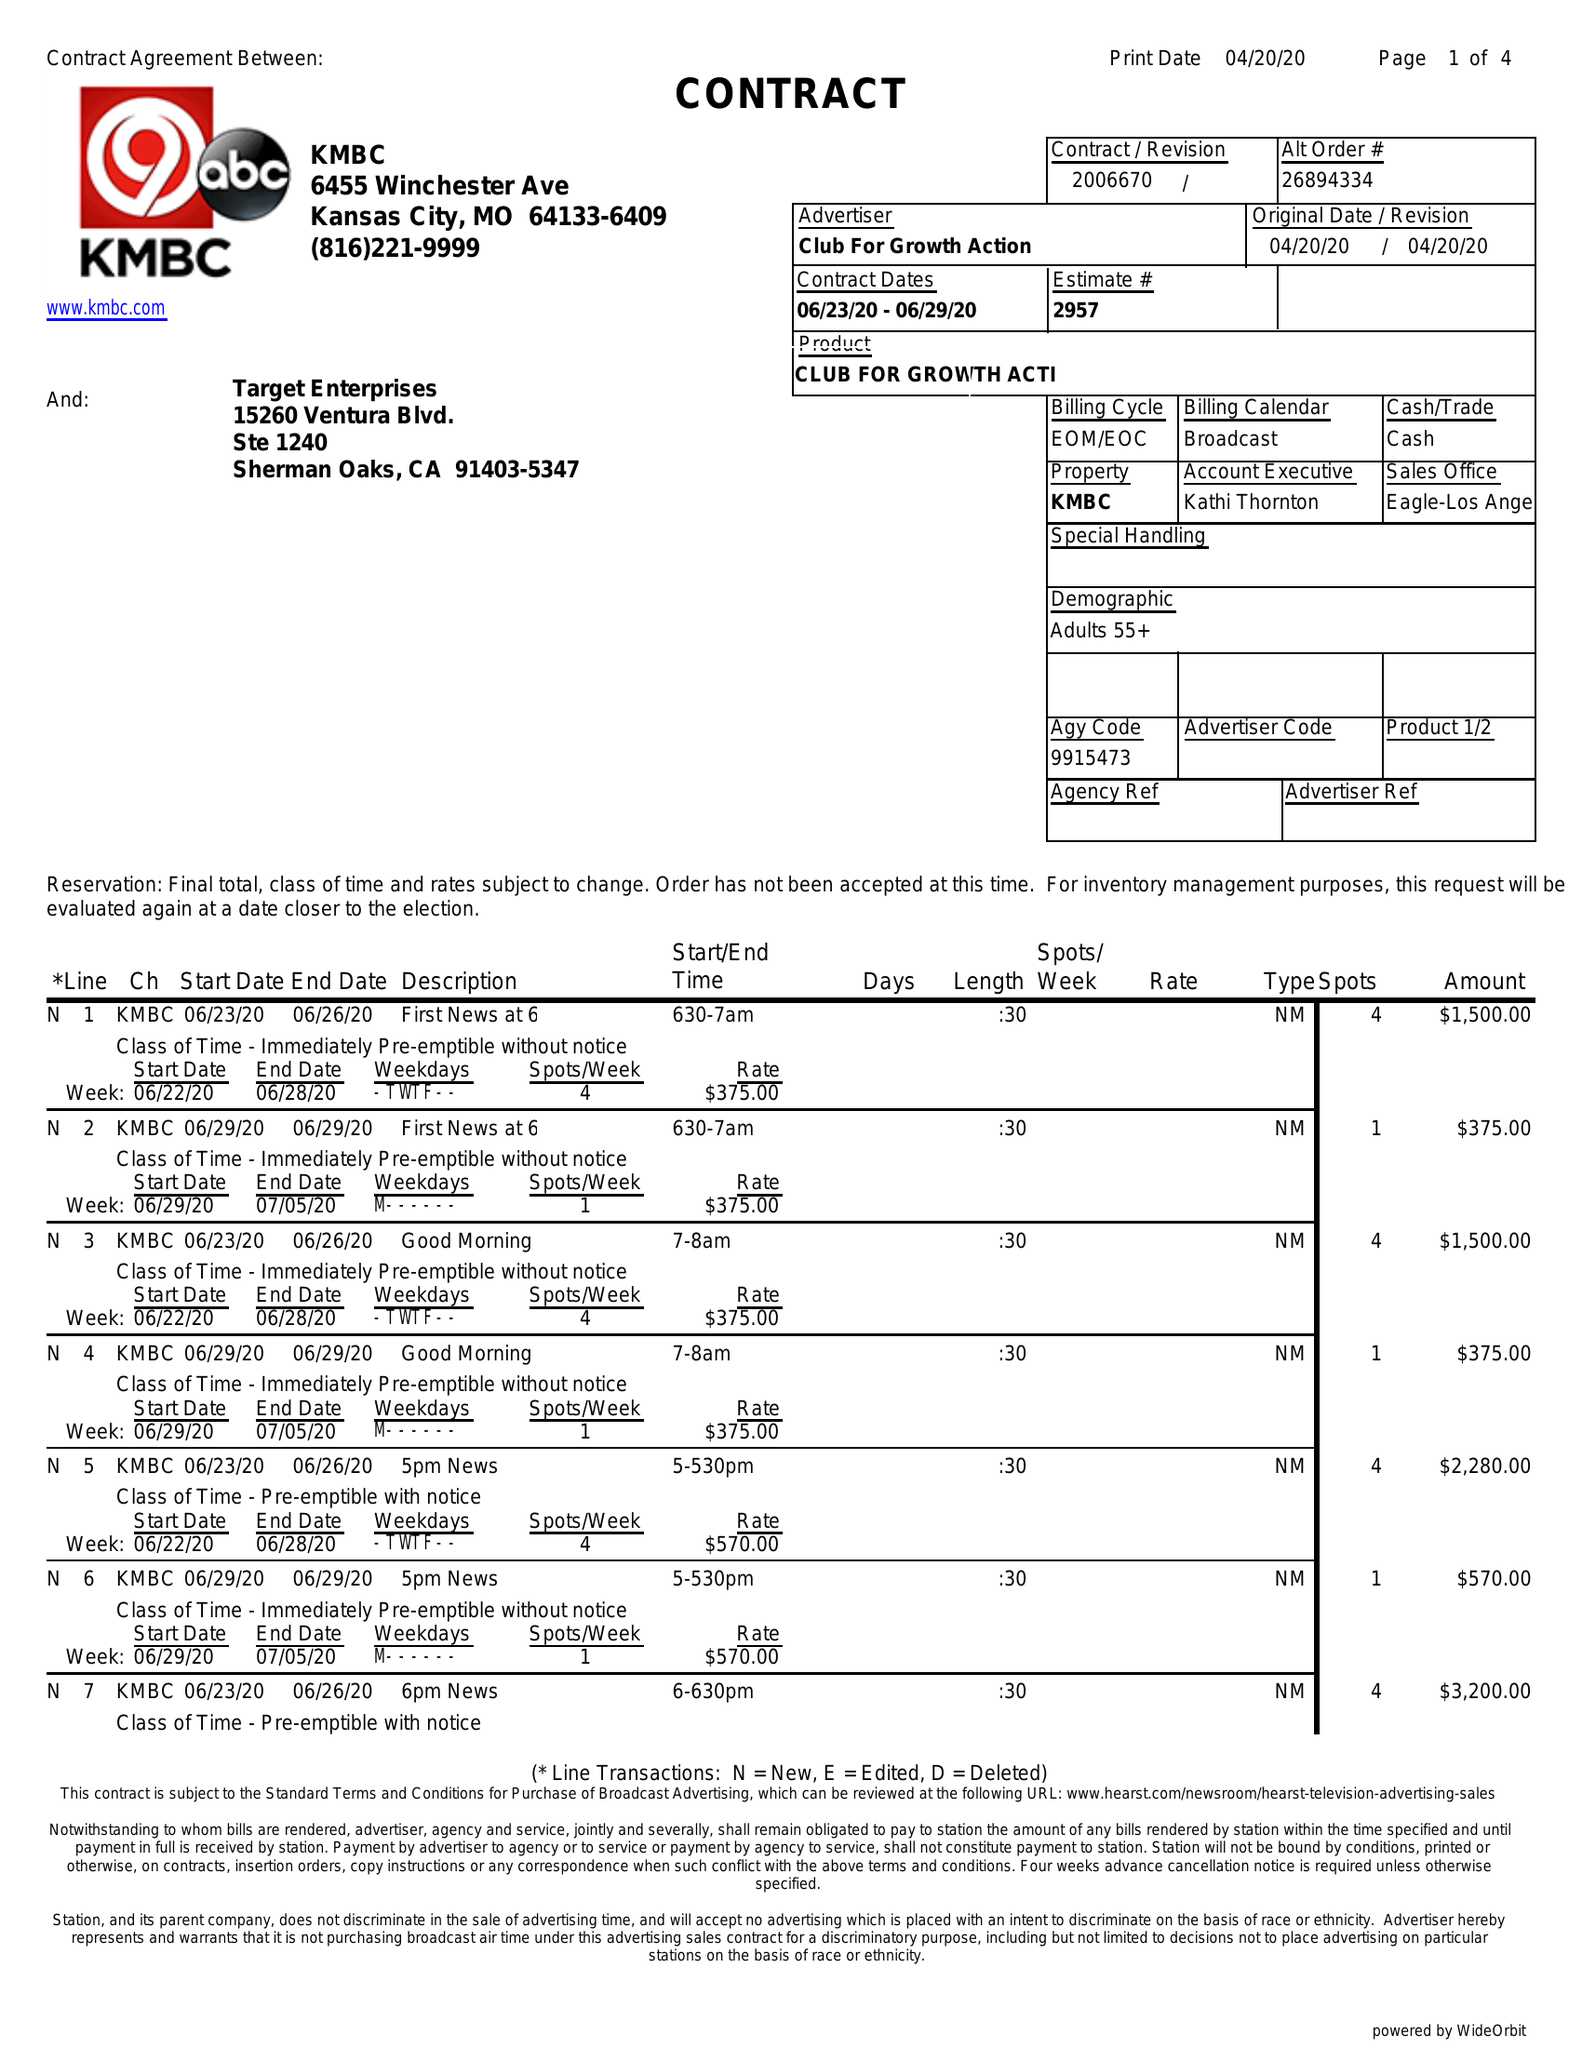What is the value for the flight_to?
Answer the question using a single word or phrase. 06/29/20 